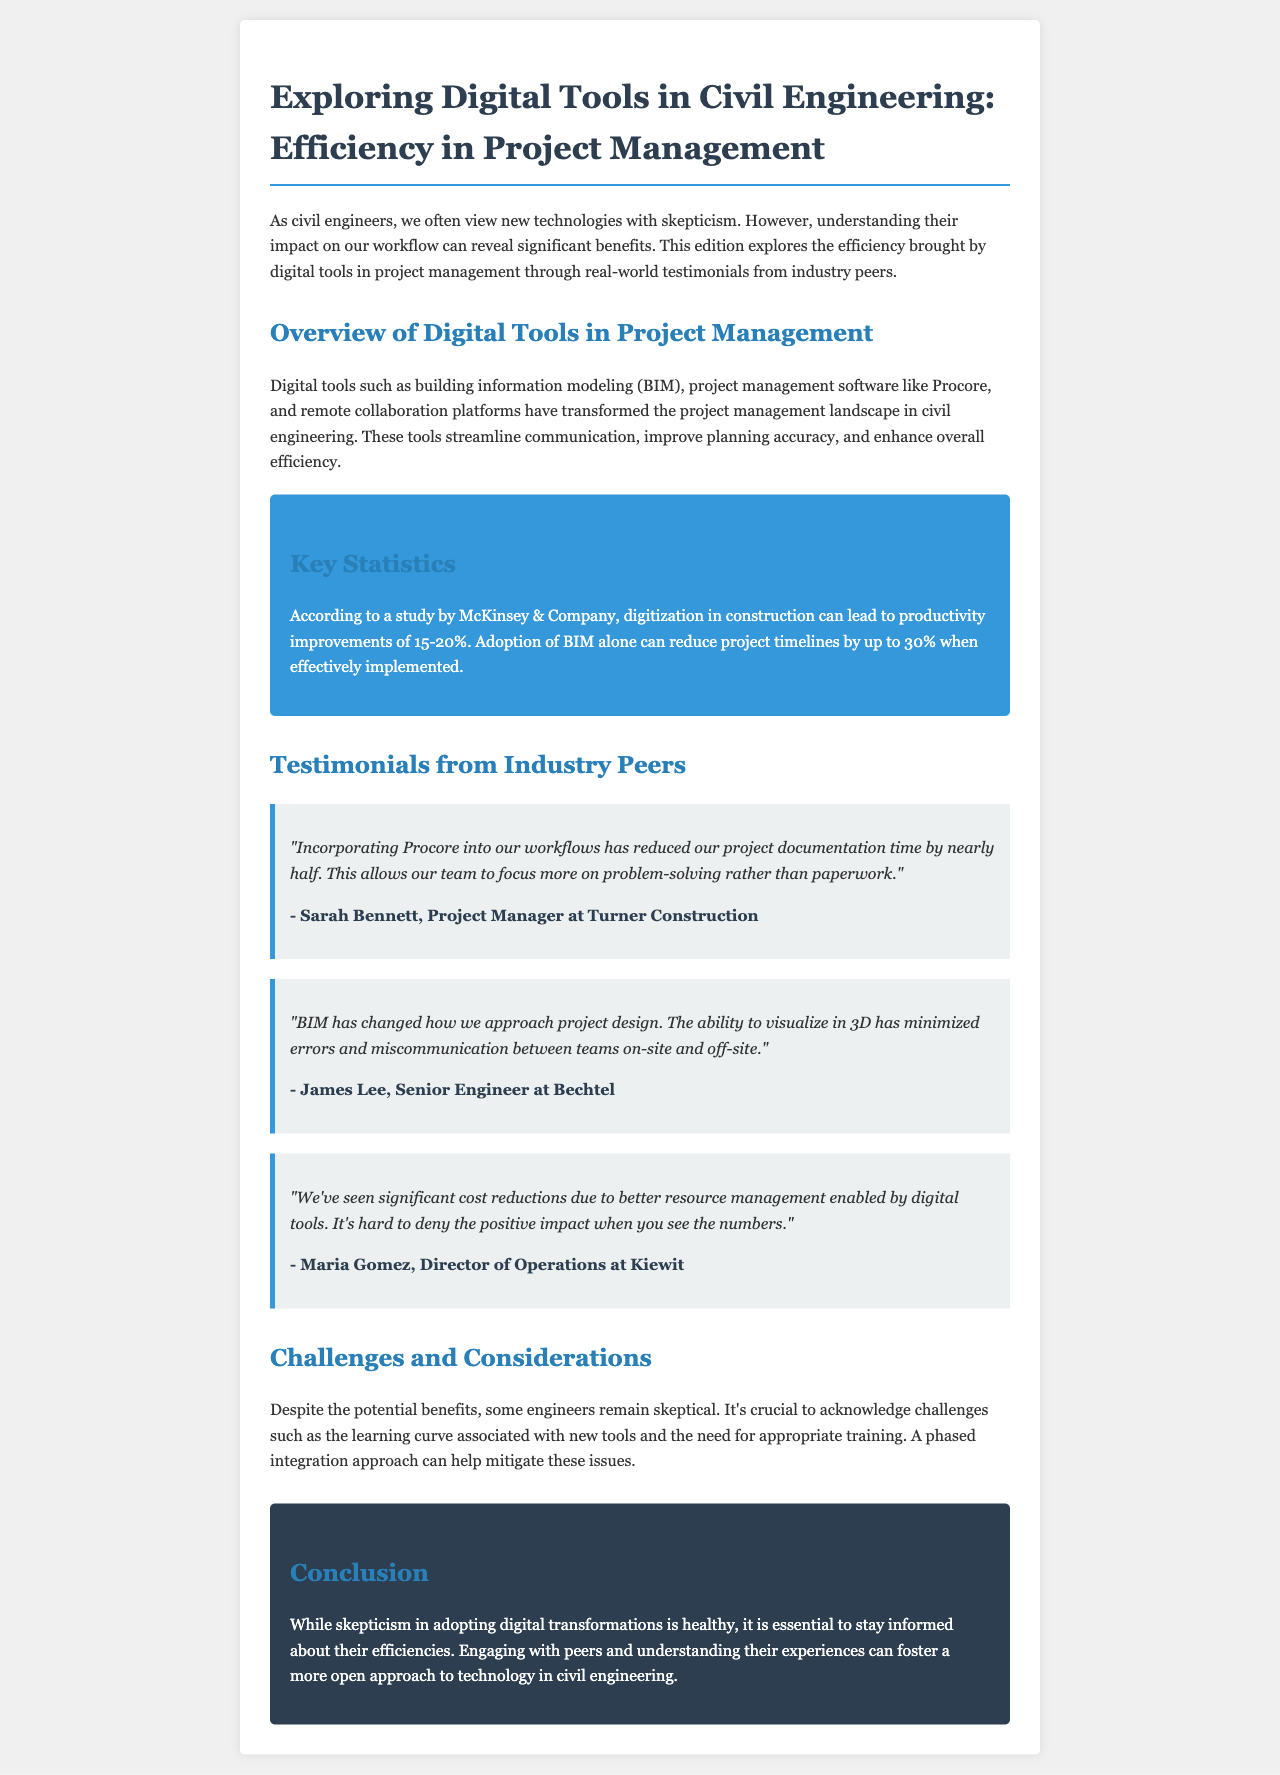What is the main topic of the newsletter? The main topic discusses the impact of digital tools on project management efficiency in civil engineering.
Answer: Digital tools in civil engineering Who mentioned the use of Procore in their testimonial? Sarah Bennett is the person who provided a testimonial about using Procore.
Answer: Sarah Bennett What percentage of productivity improvement can digitization in construction lead to? The document states that digitization in construction can lead to productivity improvements of 15-20%.
Answer: 15-20% What is one significant benefit of BIM mentioned in the testimonials? James Lee states that BIM has minimized errors and miscommunication between teams.
Answer: Minimized errors and miscommunication According to the document, what is a challenge associated with digital tools? The document mentions the learning curve associated with new tools as a challenge.
Answer: Learning curve What company does Maria Gomez work for? Maria Gomez works for Kiewit, as stated in her testimonial.
Answer: Kiewit What is the purpose of the newsletter? The newsletter aims to explore the efficiency brought by digital tools in project management.
Answer: Explore efficiency Which section provides real-world experiences from industry professionals? The section titled "Testimonials from Industry Peers" provides real-world experiences.
Answer: Testimonials from Industry Peers 